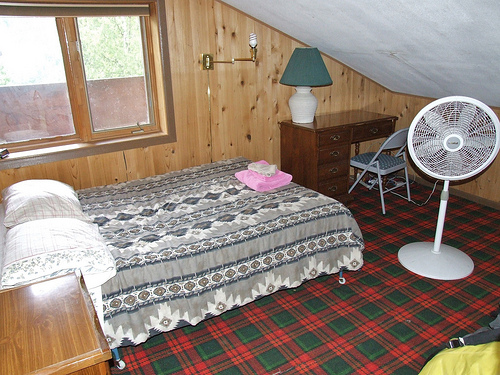<image>
Is there a towel on the bed? Yes. Looking at the image, I can see the towel is positioned on top of the bed, with the bed providing support. Where is the lamp in relation to the fan? Is it behind the fan? Yes. From this viewpoint, the lamp is positioned behind the fan, with the fan partially or fully occluding the lamp. Is the window behind the bed? Yes. From this viewpoint, the window is positioned behind the bed, with the bed partially or fully occluding the window. Is there a pillow next to the fan? No. The pillow is not positioned next to the fan. They are located in different areas of the scene. 